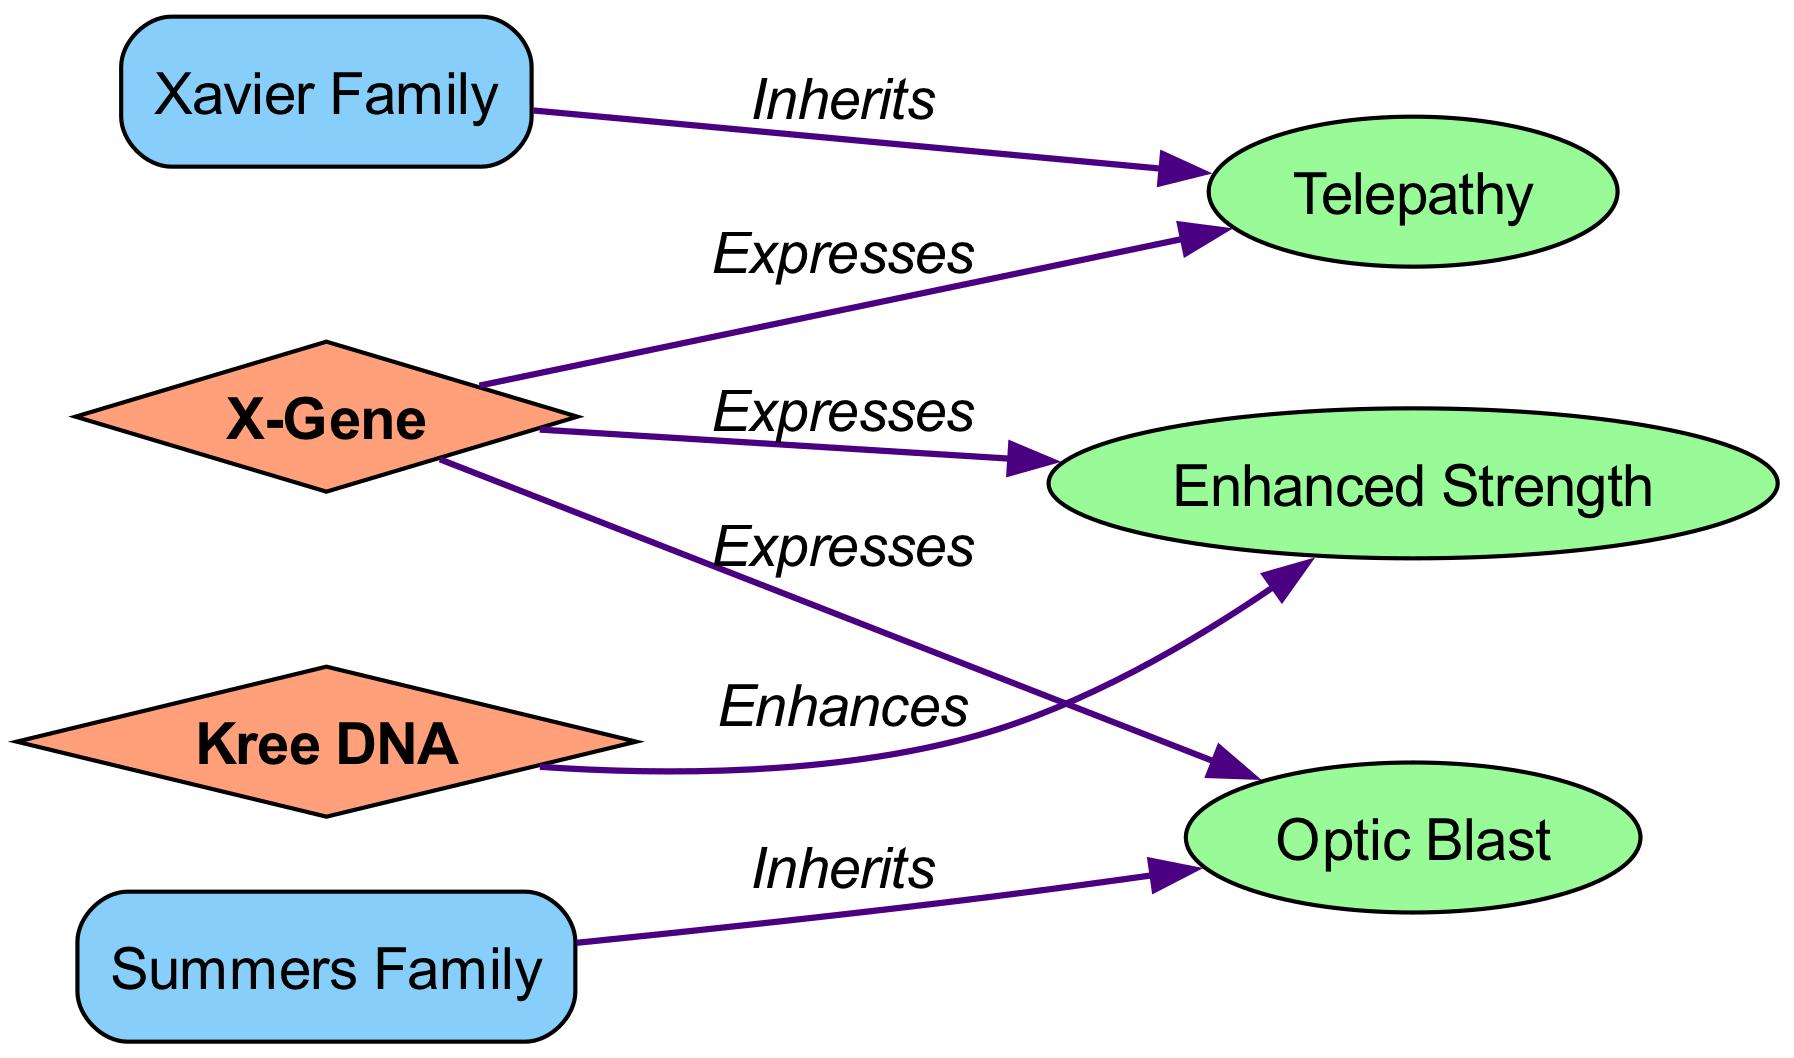What gene is associated with telepathy? The diagram indicates that the X-Gene expresses telepathy, as shown by the edge connecting the X-Gene node to the Telepathy trait node labeled "Expresses."
Answer: X-Gene How many families are represented in the diagram? There are two families depicted in the diagram: Xavier Family and Summers Family. This can be counted directly from the nodes labeled as families.
Answer: 2 What trait does the Summers Family inherit? The Summers Family inherits the Optic Blast trait, as indicated by the edge connecting the Summers Family node to the Optic Blast trait node labeled "Inherits."
Answer: Optic Blast Which gene enhances Enhanced Strength? The diagram shows that Kree DNA enhances Enhanced Strength, according to the edge between Kree DNA and the Enhanced Strength trait labeled "Enhances."
Answer: Kree DNA What is the relationship between the X-Gene and Enhanced Strength? The diagram illustrates that the X-Gene expresses Enhanced Strength, indicated by the edge linking the X-Gene to the Enhanced Strength trait node labeled "Expresses."
Answer: Expresses How many edges are there in the diagram? There are five edges illustrated in the diagram, connecting the various genes, traits, and families. This can be counted by looking at the connections made in the edges section.
Answer: 5 Which trait is inherited by the Xavier Family? The Xavier Family inherits the Telepathy trait, as shown by the edge connecting the Xavier Family node to the Telepathy trait node labeled "Inherits."
Answer: Telepathy What does the Kree DNA gene enhance? Kree DNA enhances Enhanced Strength, as indicated by the edge from Kree DNA to Enhanced Strength labeled "Enhances."
Answer: Enhanced Strength 